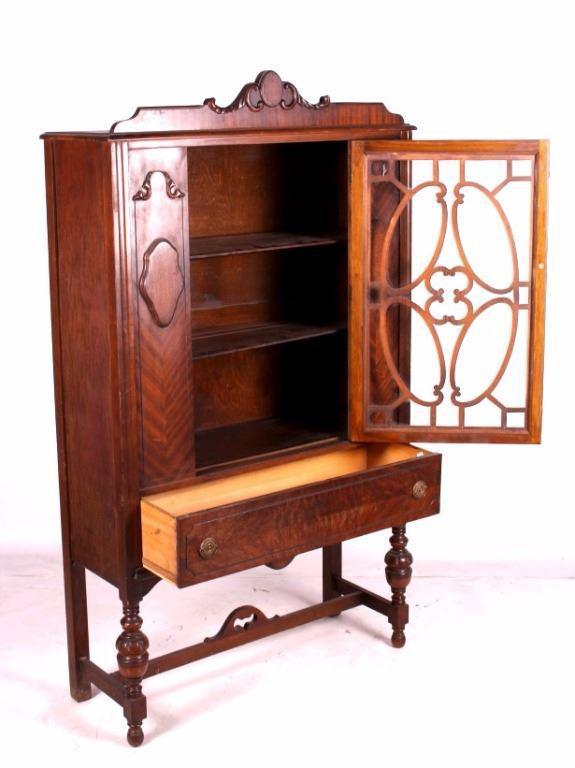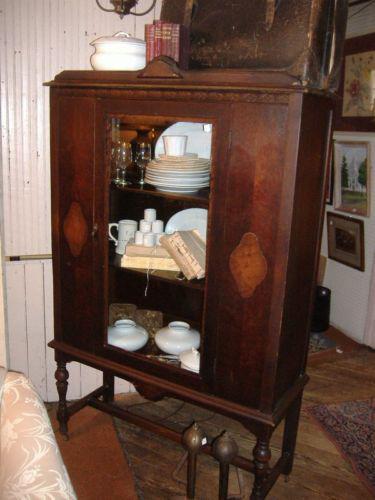The first image is the image on the left, the second image is the image on the right. Assess this claim about the two images: "There are dishes in one of the cabinets.". Correct or not? Answer yes or no. Yes. 